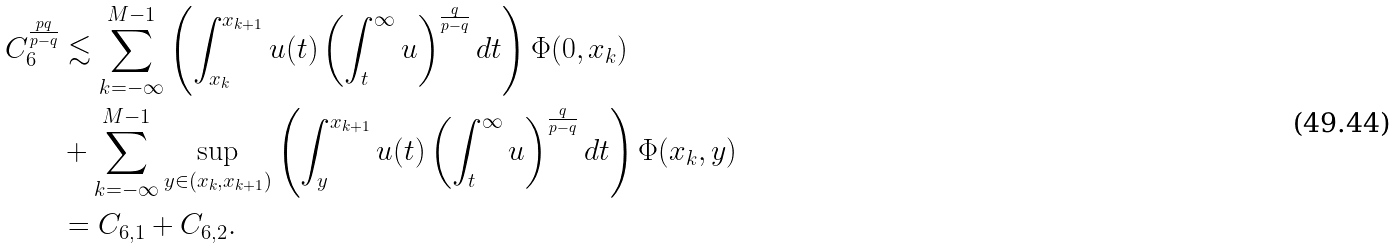Convert formula to latex. <formula><loc_0><loc_0><loc_500><loc_500>C _ { 6 } ^ { \frac { p q } { p - q } } & \lesssim \sum _ { k = - \infty } ^ { M - 1 } \left ( \int _ { x _ { k } } ^ { x _ { k + 1 } } u ( t ) \left ( \int _ { t } ^ { \infty } u \right ) ^ { \frac { q } { p - q } } d t \right ) \Phi ( 0 , x _ { k } ) \\ & + \sum _ { k = - \infty } ^ { M - 1 } \sup _ { y \in ( x _ { k } , x _ { k + 1 } ) } \left ( \int _ { y } ^ { x _ { k + 1 } } u ( t ) \left ( \int _ { t } ^ { \infty } u \right ) ^ { \frac { q } { p - q } } d t \right ) \Phi ( x _ { k } , y ) \\ & = C _ { 6 , 1 } + C _ { 6 , 2 } .</formula> 